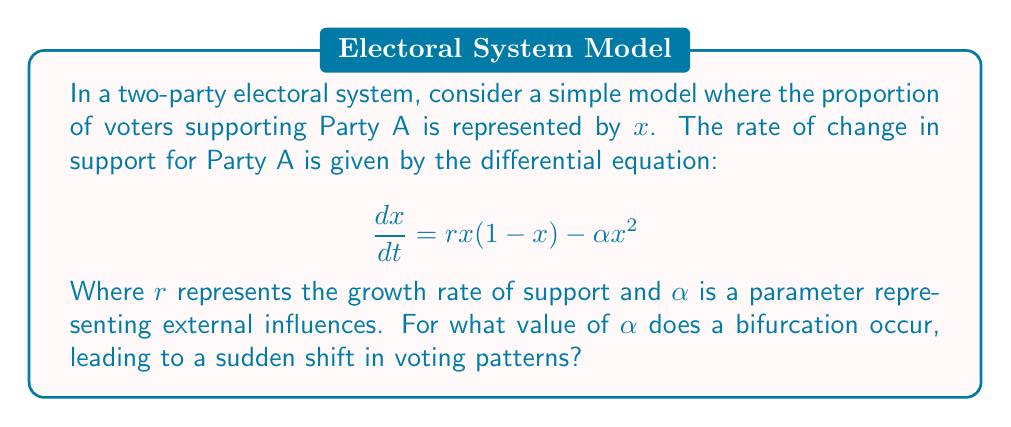Teach me how to tackle this problem. To find the bifurcation point, we need to follow these steps:

1) First, find the equilibrium points by setting $\frac{dx}{dt} = 0$:

   $$rx(1-x) - \alpha x^2 = 0$$

2) Factor out $x$:

   $$x(r(1-x) - \alpha x) = 0$$

3) Solve for $x$:
   
   $x = 0$ or $r(1-x) - \alpha x = 0$

4) For the non-zero equilibrium:

   $$r - rx - \alpha x = 0$$
   $$r = x(r + \alpha)$$
   $$x = \frac{r}{r + \alpha}$$

5) The bifurcation occurs when this non-zero equilibrium coincides with $x = 0$, i.e., when $\frac{r}{r + \alpha} = 0$

6) This happens when the denominator approaches infinity, or when $\alpha$ approaches $-r$

Therefore, the bifurcation occurs when $\alpha = r$.
Answer: $\alpha = r$ 